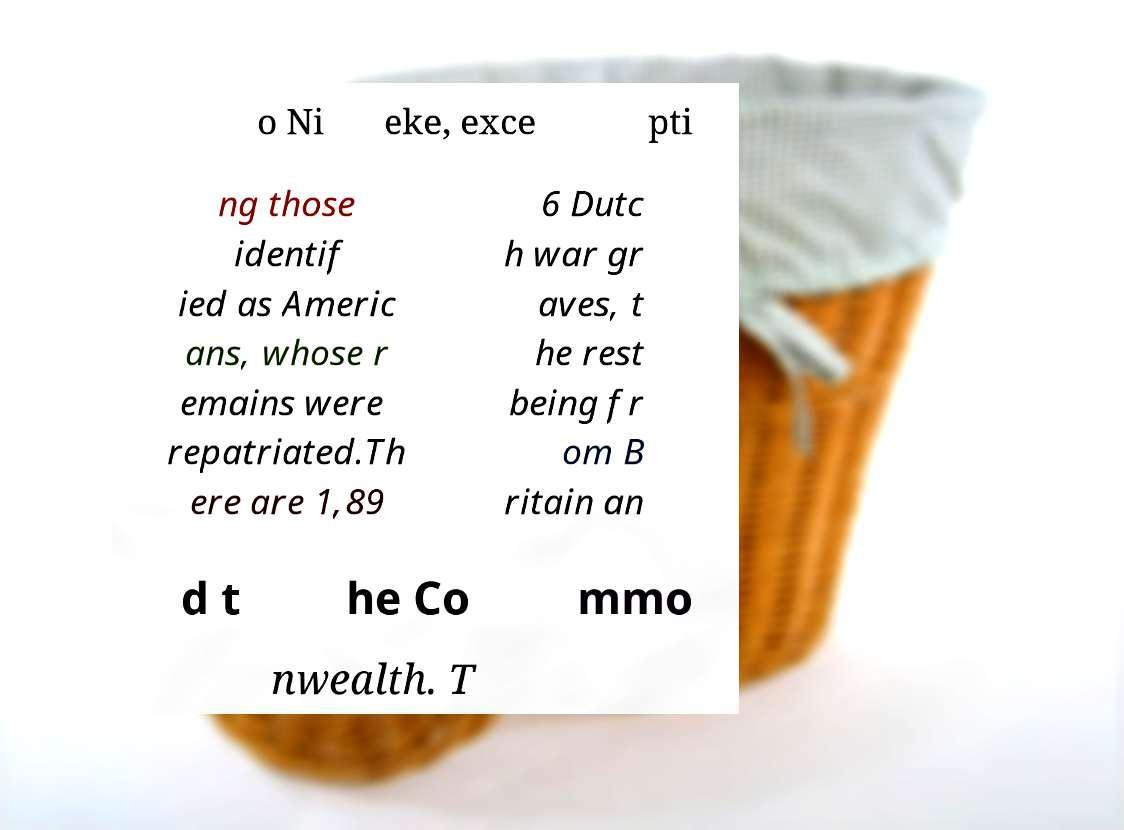What messages or text are displayed in this image? I need them in a readable, typed format. o Ni eke, exce pti ng those identif ied as Americ ans, whose r emains were repatriated.Th ere are 1,89 6 Dutc h war gr aves, t he rest being fr om B ritain an d t he Co mmo nwealth. T 